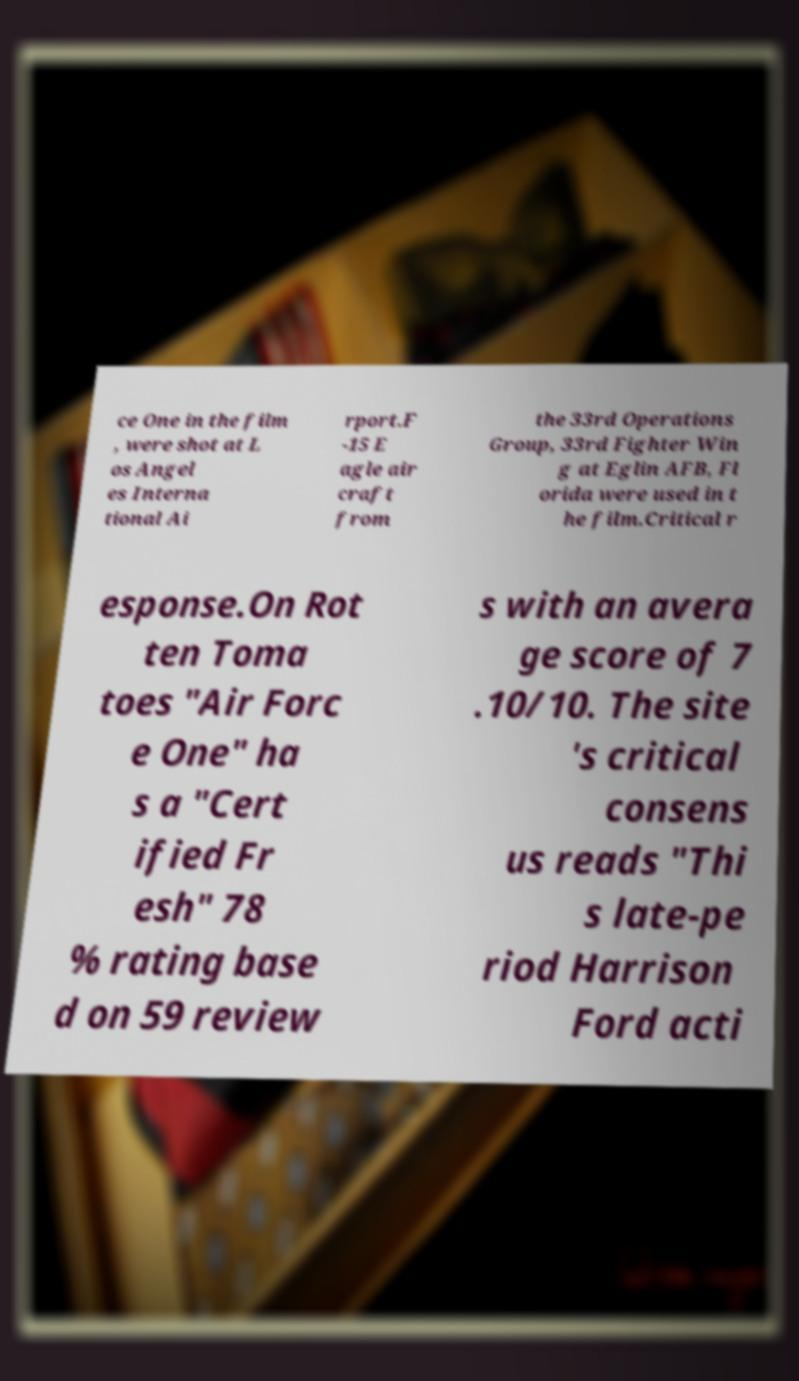What messages or text are displayed in this image? I need them in a readable, typed format. ce One in the film , were shot at L os Angel es Interna tional Ai rport.F -15 E agle air craft from the 33rd Operations Group, 33rd Fighter Win g at Eglin AFB, Fl orida were used in t he film.Critical r esponse.On Rot ten Toma toes "Air Forc e One" ha s a "Cert ified Fr esh" 78 % rating base d on 59 review s with an avera ge score of 7 .10/10. The site 's critical consens us reads "Thi s late-pe riod Harrison Ford acti 